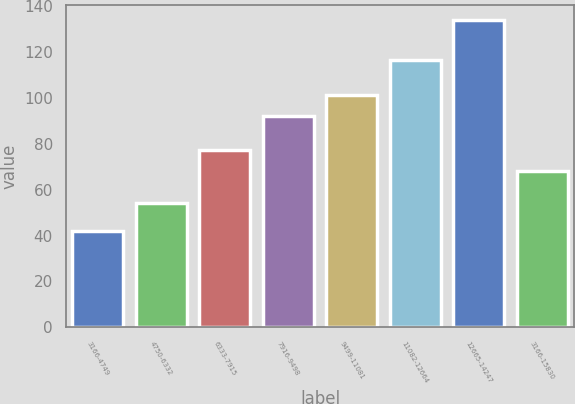Convert chart. <chart><loc_0><loc_0><loc_500><loc_500><bar_chart><fcel>3166-4749<fcel>4750-6332<fcel>6333-7915<fcel>7916-9498<fcel>9499-11081<fcel>11082-12664<fcel>12665-14247<fcel>3166-15830<nl><fcel>41.82<fcel>54.1<fcel>77.22<fcel>92.24<fcel>101.44<fcel>116.27<fcel>133.77<fcel>68.02<nl></chart> 